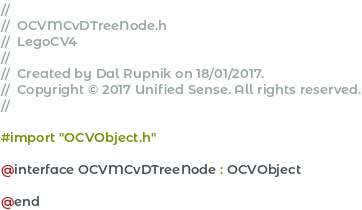Convert code to text. <code><loc_0><loc_0><loc_500><loc_500><_C_>//
//  OCVMCvDTreeNode.h
//  LegoCV4
//
//  Created by Dal Rupnik on 18/01/2017.
//  Copyright © 2017 Unified Sense. All rights reserved.
//

#import "OCVObject.h"

@interface OCVMCvDTreeNode : OCVObject

@end
</code> 